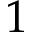Convert formula to latex. <formula><loc_0><loc_0><loc_500><loc_500>1</formula> 